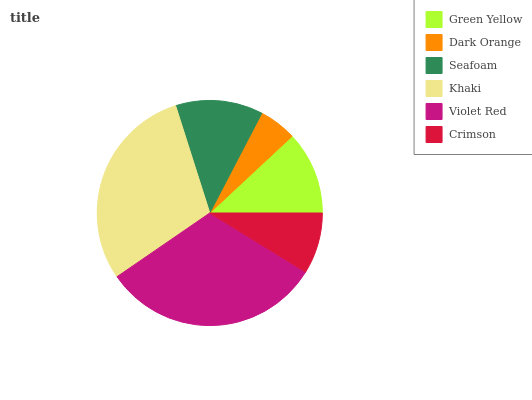Is Dark Orange the minimum?
Answer yes or no. Yes. Is Violet Red the maximum?
Answer yes or no. Yes. Is Seafoam the minimum?
Answer yes or no. No. Is Seafoam the maximum?
Answer yes or no. No. Is Seafoam greater than Dark Orange?
Answer yes or no. Yes. Is Dark Orange less than Seafoam?
Answer yes or no. Yes. Is Dark Orange greater than Seafoam?
Answer yes or no. No. Is Seafoam less than Dark Orange?
Answer yes or no. No. Is Seafoam the high median?
Answer yes or no. Yes. Is Green Yellow the low median?
Answer yes or no. Yes. Is Violet Red the high median?
Answer yes or no. No. Is Violet Red the low median?
Answer yes or no. No. 